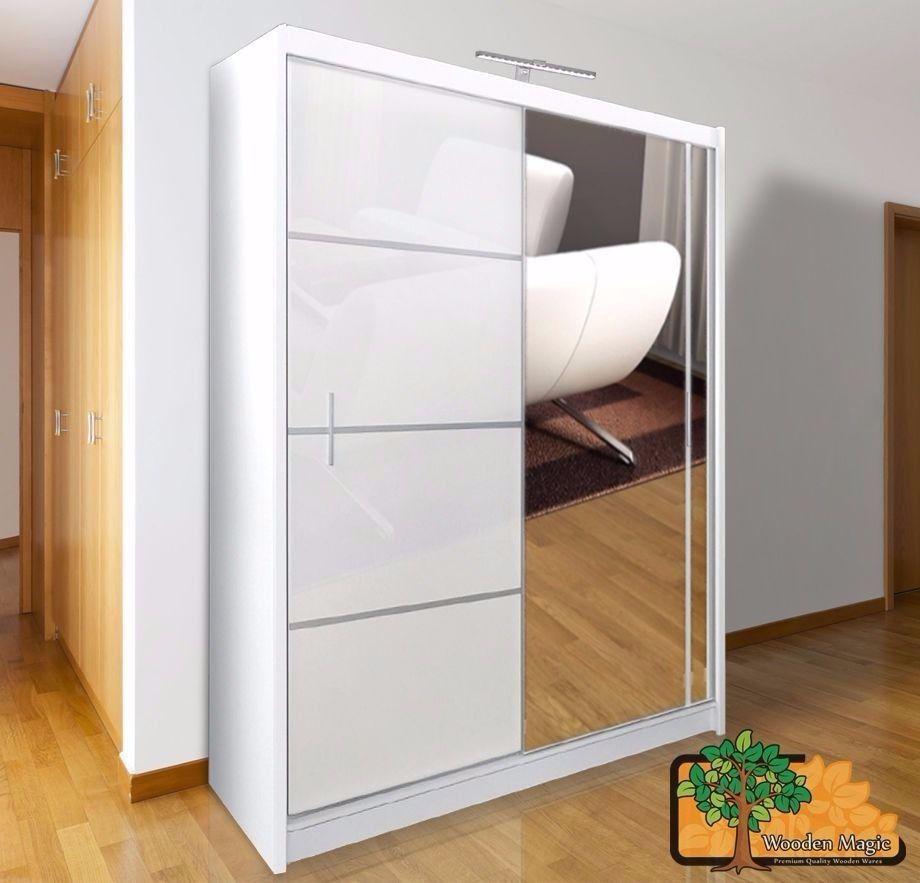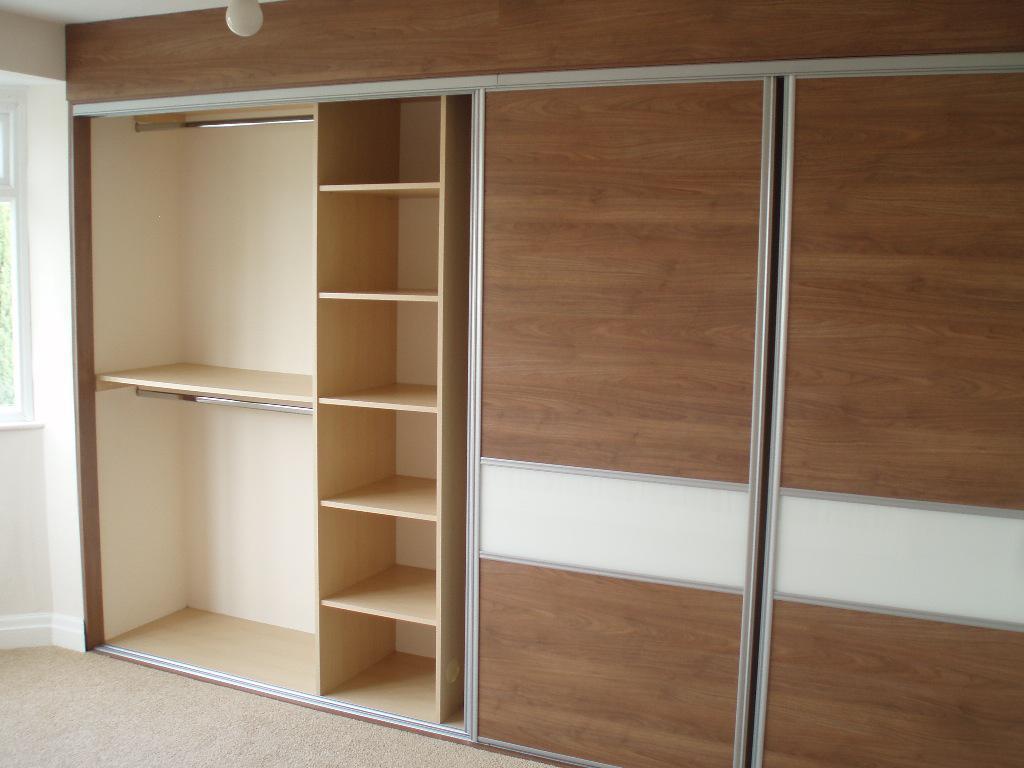The first image is the image on the left, the second image is the image on the right. For the images shown, is this caption "One image shows a single white wardrobe, with an open area where clothes hang on the left." true? Answer yes or no. No. The first image is the image on the left, the second image is the image on the right. Given the left and right images, does the statement "Clothing is hanging in the wardrobe in the image on the right." hold true? Answer yes or no. No. 